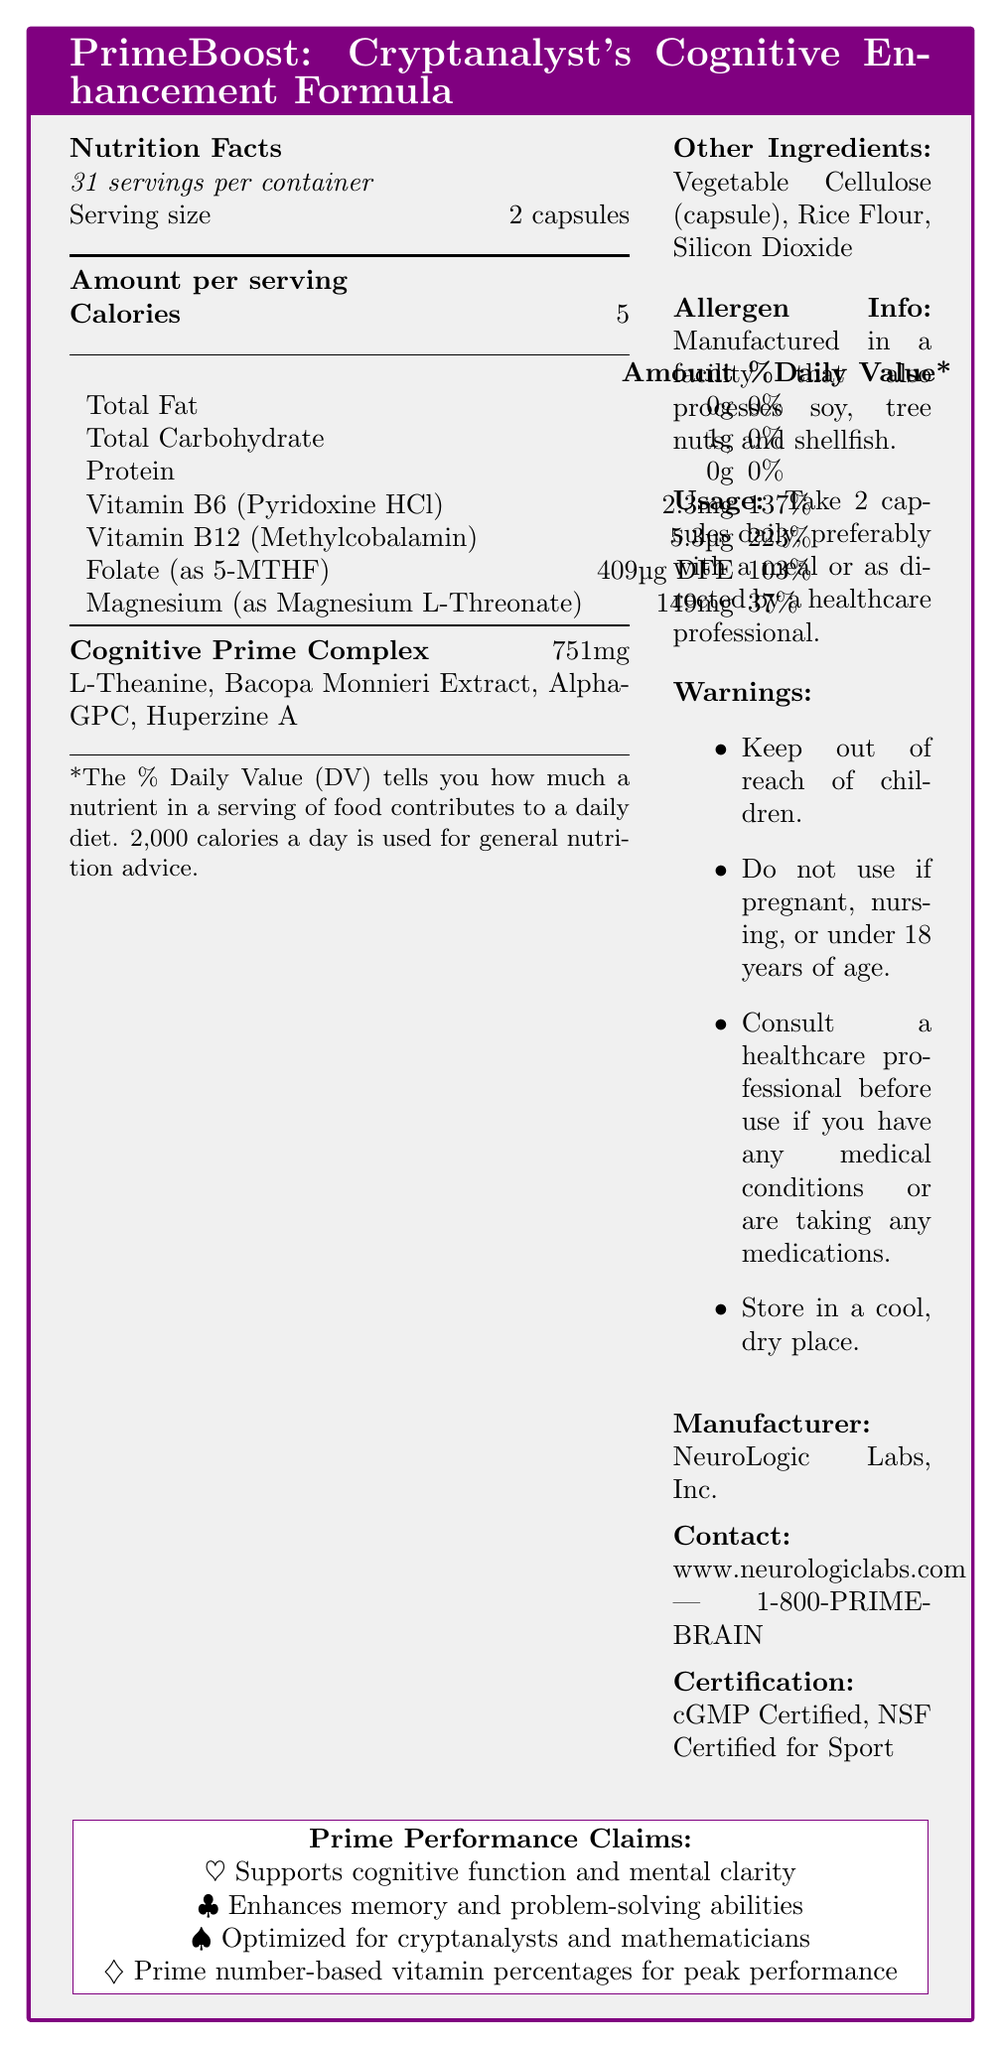what is the serving size for PrimeBoost? The serving size is explicitly mentioned in the document under the "Nutrition Facts" section as "Serving size 2 capsules".
Answer: 2 capsules how many calories are in each serving of PrimeBoost? The number of calories per serving is given in the "Nutrition Facts" section under "Amount per serving", which lists "Calories" as 5.
Answer: 5 what is the daily percentage value of Vitamin B12 contained in PrimeBoost? In the "Nutrition Facts" section, it lists the daily percentage value for Vitamin B12 (Methylcobalamin) as 223%.
Answer: 223% name two ingredients included in the Cognitive Prime Complex blend. The "Cognitive Prime Complex" section lists the ingredients: "L-Theanine, Bacopa Monnieri Extract, Alpha-GPC, Huperzine A".
Answer: L-Theanine, Bacopa Monnieri Extract which certification does PrimeBoost hold? The document states at the bottom of the right column: "Certification: cGMP Certified, NSF Certified for Sport".
Answer: cGMP Certified, NSF Certified for Sport how many servings are there per container of PrimeBoost? This is stated at the top of the "Nutrition Facts" section as “31 servings per container”.
Answer: 31 what is the total carbohydrate content per serving? The "Nutrition Facts" section lists "Total Carbohydrate" as 1g per serving.
Answer: 1g what is the suggested usage for PrimeBoost? In the right column under "Usage," it states "Take 2 capsules daily, preferably with a meal or as directed by a healthcare professional."
Answer: Take 2 capsules daily, preferably with a meal or as directed by a healthcare professional which company manufactures PrimeBoost? The manufacturer information is provided in the right column as "Manufacturer: NeuroLogic Labs, Inc."
Answer: NeuroLogic Labs, Inc. is PrimeBoost suitable for pregnant women? The "Warnings" section states "Do not use if pregnant, nursing, or under 18 years of age."
Answer: No which of the following vitamins in PrimeBoost has the smallest amount per serving? A. Vitamin B6 B. Vitamin B12 C. Folate D. Magnesium As per the "Nutrition Facts," section, Vitamin B12 (5.3 µg) has the smallest amount.
Answer: B. Vitamin B12 what is the total proprietary blend content in PrimeBoost? A. 751mg B. 137% C. 149mg D. 223% The document lists "Cognitive Prime Complex" under proprietary blend content as 751mg.
Answer: A. 751mg is the product contained in a cGMP certified facility? The document states that PrimeBoost is "cGMP Certified."
Answer: Yes summarize the main benefits of PrimeBoost This is summarized from the "Prime Performance Claims" section, outlining the key benefits of the product.
Answer: PrimeBoost is a cognitive enhancement supplement designed to support cognitive function and mental clarity, enhance memory and problem-solving abilities, and is optimized for cryptanalysts and mathematicians with prime number-based vitamin percentages for peak performance. what is the specific form of Folate used in PrimeBoost? The "Nutrition Facts" lists Folate as being in the form of "5-MTHF" (409 µg DFE).
Answer: 5-MTHF is PrimeBoost gluten-free? The document does not provide any information regarding whether PrimeBoost is gluten-free.
Answer: Not enough information 